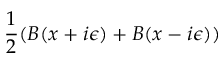Convert formula to latex. <formula><loc_0><loc_0><loc_500><loc_500>\frac { 1 } { 2 } ( B ( x + i \epsilon ) + B ( x - i \epsilon ) )</formula> 